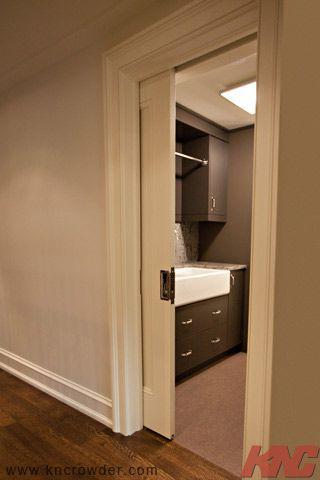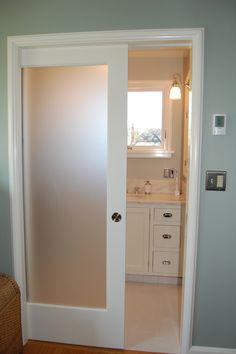The first image is the image on the left, the second image is the image on the right. Examine the images to the left and right. Is the description "One sliding door is partially open and showing a bathroom behind it." accurate? Answer yes or no. Yes. 